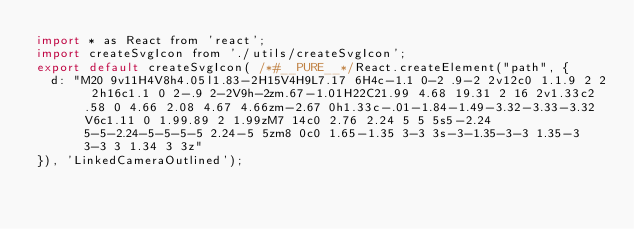<code> <loc_0><loc_0><loc_500><loc_500><_JavaScript_>import * as React from 'react';
import createSvgIcon from './utils/createSvgIcon';
export default createSvgIcon( /*#__PURE__*/React.createElement("path", {
  d: "M20 9v11H4V8h4.05l1.83-2H15V4H9L7.17 6H4c-1.1 0-2 .9-2 2v12c0 1.1.9 2 2 2h16c1.1 0 2-.9 2-2V9h-2zm.67-1.01H22C21.99 4.68 19.31 2 16 2v1.33c2.58 0 4.66 2.08 4.67 4.66zm-2.67 0h1.33c-.01-1.84-1.49-3.32-3.33-3.32V6c1.11 0 1.99.89 2 1.99zM7 14c0 2.76 2.24 5 5 5s5-2.24 5-5-2.24-5-5-5-5 2.24-5 5zm8 0c0 1.65-1.35 3-3 3s-3-1.35-3-3 1.35-3 3-3 3 1.34 3 3z"
}), 'LinkedCameraOutlined');</code> 